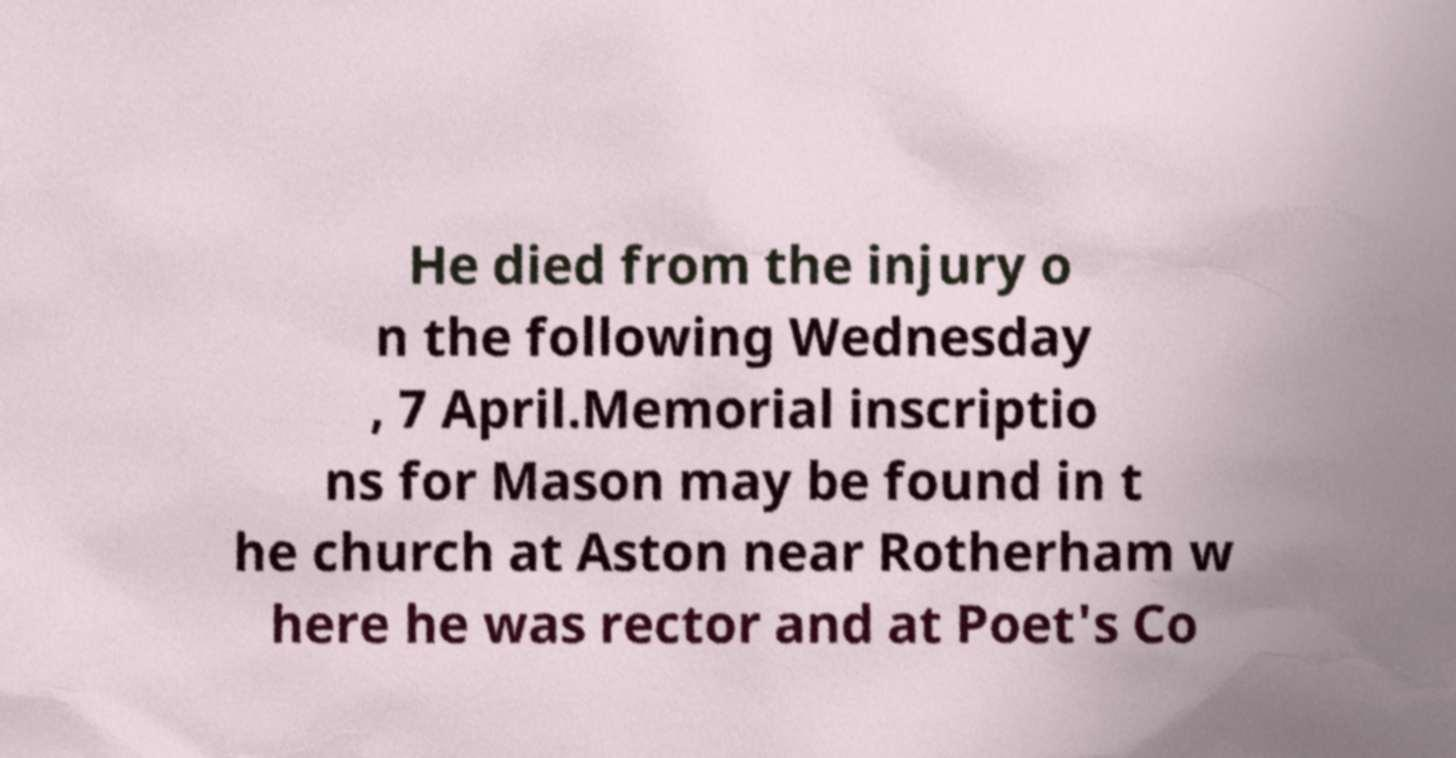Please identify and transcribe the text found in this image. He died from the injury o n the following Wednesday , 7 April.Memorial inscriptio ns for Mason may be found in t he church at Aston near Rotherham w here he was rector and at Poet's Co 